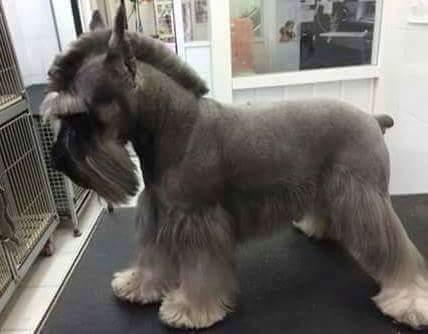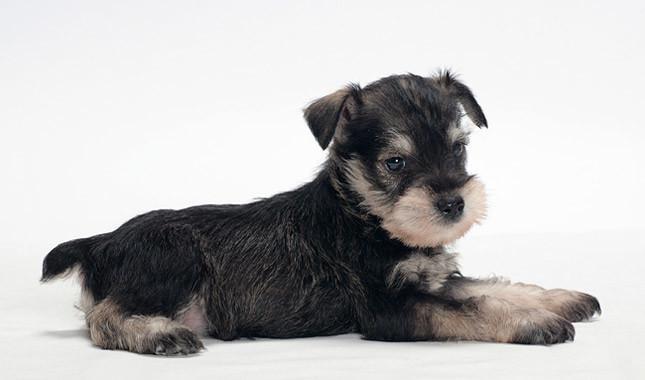The first image is the image on the left, the second image is the image on the right. Examine the images to the left and right. Is the description "Only one little dog is wearing a collar." accurate? Answer yes or no. No. The first image is the image on the left, the second image is the image on the right. Given the left and right images, does the statement "Both images contain exactly one dog that is standing on grass." hold true? Answer yes or no. No. The first image is the image on the left, the second image is the image on the right. For the images shown, is this caption "One dog has a red collar." true? Answer yes or no. No. The first image is the image on the left, the second image is the image on the right. For the images shown, is this caption "Both dogs are standing on the grass." true? Answer yes or no. No. 